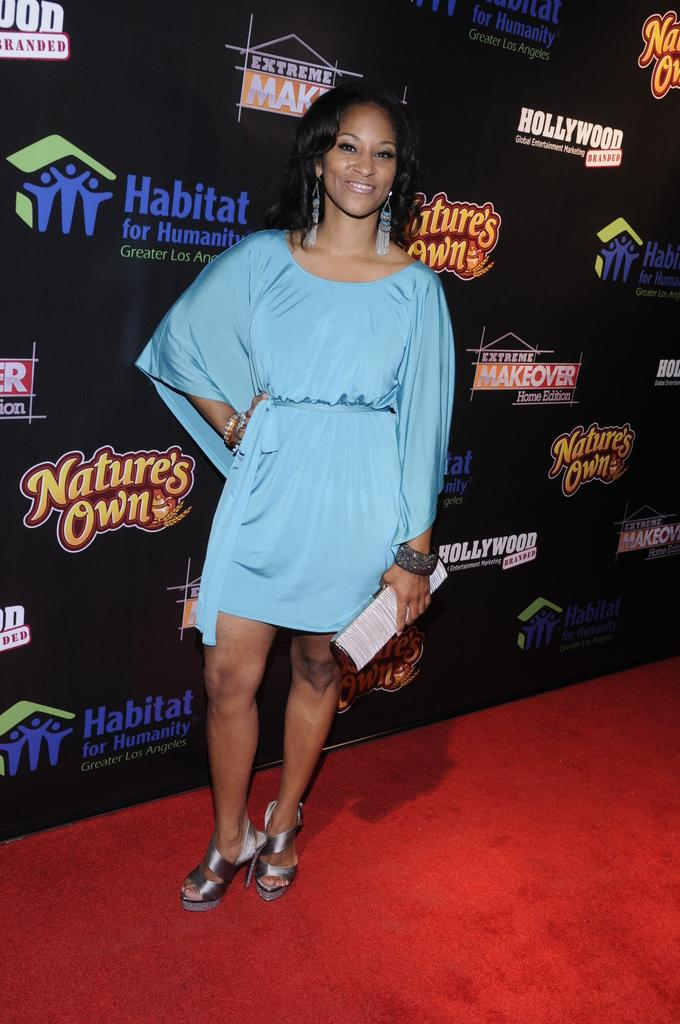Who is the main subject in the image? There is a woman in the image. What is the woman wearing? The woman is wearing a blue dress. What expression does the woman have? The woman is smiling. What can be seen in the background behind the woman? There is a hoarding visible behind the woman. What type of cooking experience does the woman have, as seen in the image? There is no indication in the image of the woman's cooking experience, as the image does not show her in a kitchen or engaged in any cooking-related activities. 